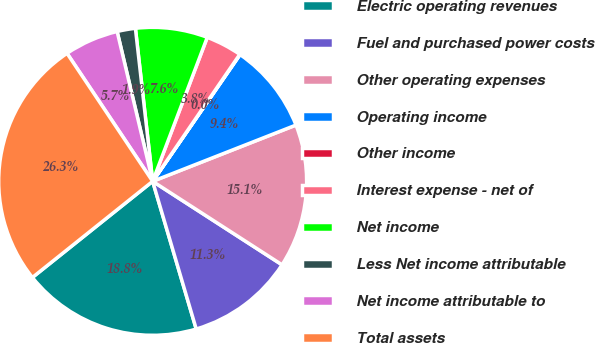Convert chart. <chart><loc_0><loc_0><loc_500><loc_500><pie_chart><fcel>Electric operating revenues<fcel>Fuel and purchased power costs<fcel>Other operating expenses<fcel>Operating income<fcel>Other income<fcel>Interest expense - net of<fcel>Net income<fcel>Less Net income attributable<fcel>Net income attributable to<fcel>Total assets<nl><fcel>18.84%<fcel>11.32%<fcel>15.08%<fcel>9.44%<fcel>0.04%<fcel>3.8%<fcel>7.56%<fcel>1.92%<fcel>5.68%<fcel>26.36%<nl></chart> 